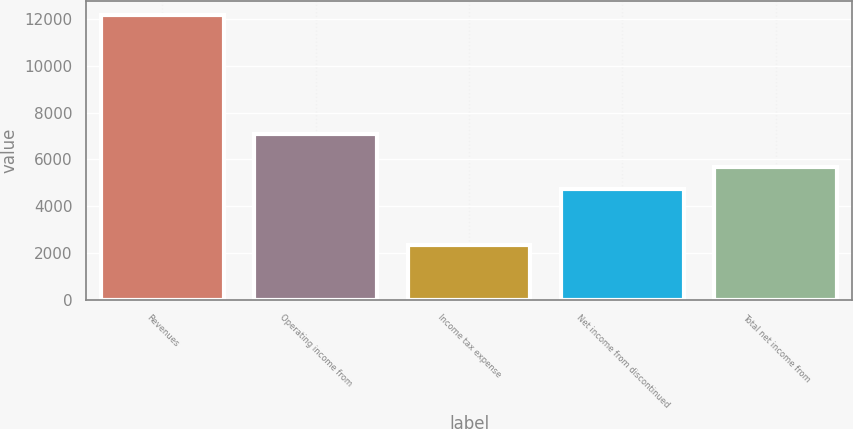<chart> <loc_0><loc_0><loc_500><loc_500><bar_chart><fcel>Revenues<fcel>Operating income from<fcel>Income tax expense<fcel>Net income from discontinued<fcel>Total net income from<nl><fcel>12162<fcel>7078<fcel>2363<fcel>4715<fcel>5694.9<nl></chart> 